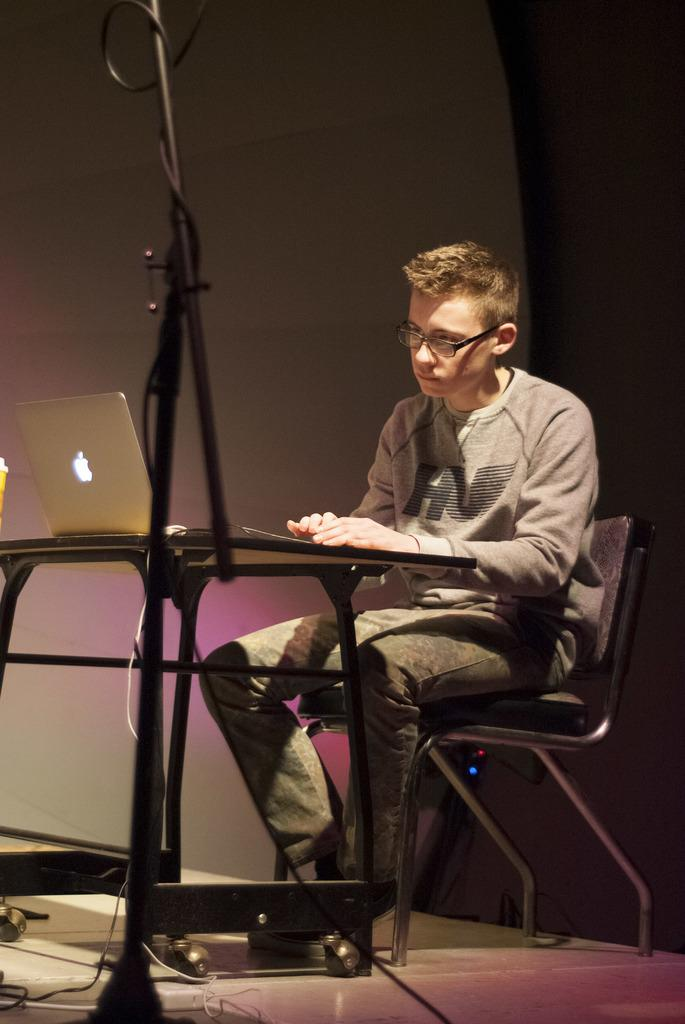Who is the main subject in the image? There is a boy in the image. What is the boy doing in the image? The boy is sitting in a chair. Where is the chair located in relation to the table? The chair is in front of a table. What device is placed on the table? A laptop is placed on the table. What accessory is the boy wearing? The boy is wearing spectacles. What can be seen in the background of the image? There is a wall in the background of the image. What type of flower is on the boy's head in the image? There is no flower present on the boy's head in the image. Does the boy have a brother in the image? The provided facts do not mention the presence of a brother in the image. 